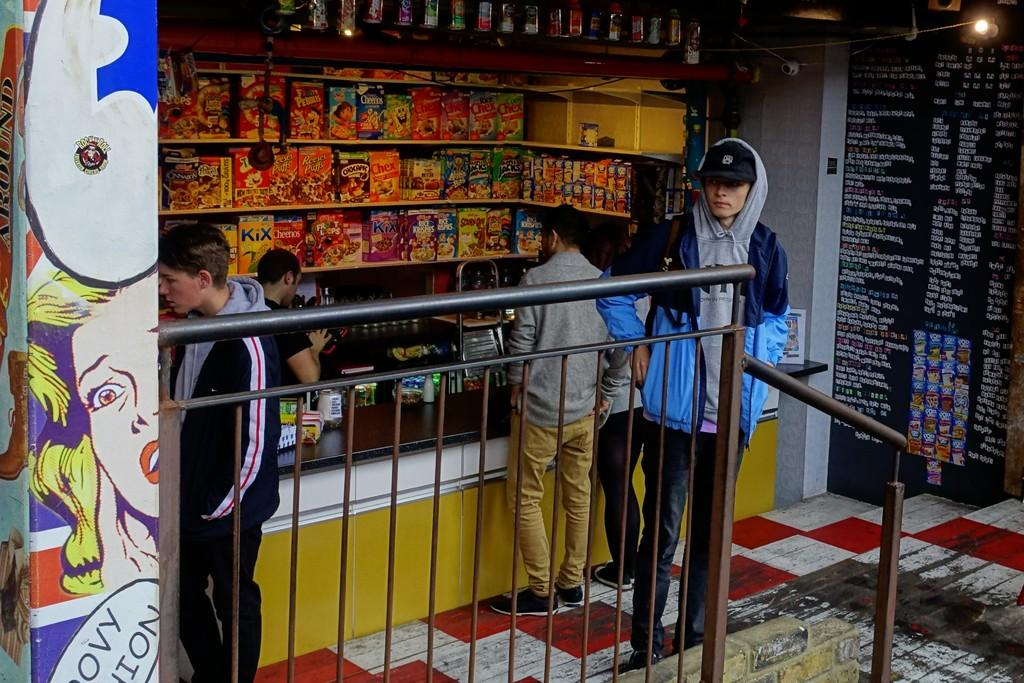What type of establishment is shown in the image? There is a shop in the image. What can be seen inside the shop? There are objects placed on shelves in the shop. Are there any people visible in the image? Yes, there are people standing in front of the shop. What type of steam is coming out of the objects on the shelves in the image? There is no steam present in the image; it is a shop with objects placed on shelves. 